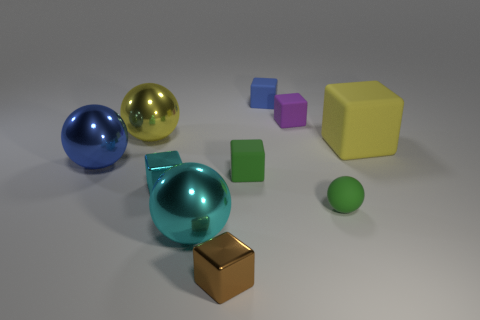The large matte cube on the right side of the small shiny thing behind the brown metallic thing is what color?
Provide a succinct answer. Yellow. There is a yellow object that is the same shape as the large blue metallic object; what is it made of?
Offer a very short reply. Metal. Are there any things in front of the large blue metal ball?
Make the answer very short. Yes. What number of brown metallic things are there?
Give a very brief answer. 1. What number of tiny cubes are in front of the big thing that is right of the purple rubber thing?
Ensure brevity in your answer.  3. There is a small sphere; does it have the same color as the rubber cube in front of the blue shiny object?
Make the answer very short. Yes. What number of other big yellow things have the same shape as the big yellow matte thing?
Offer a very short reply. 0. There is a big yellow object on the left side of the tiny cyan thing; what material is it?
Offer a very short reply. Metal. Is the shape of the large metallic thing that is behind the big yellow matte object the same as  the big cyan shiny thing?
Give a very brief answer. Yes. Are there any metal objects of the same size as the cyan ball?
Keep it short and to the point. Yes. 